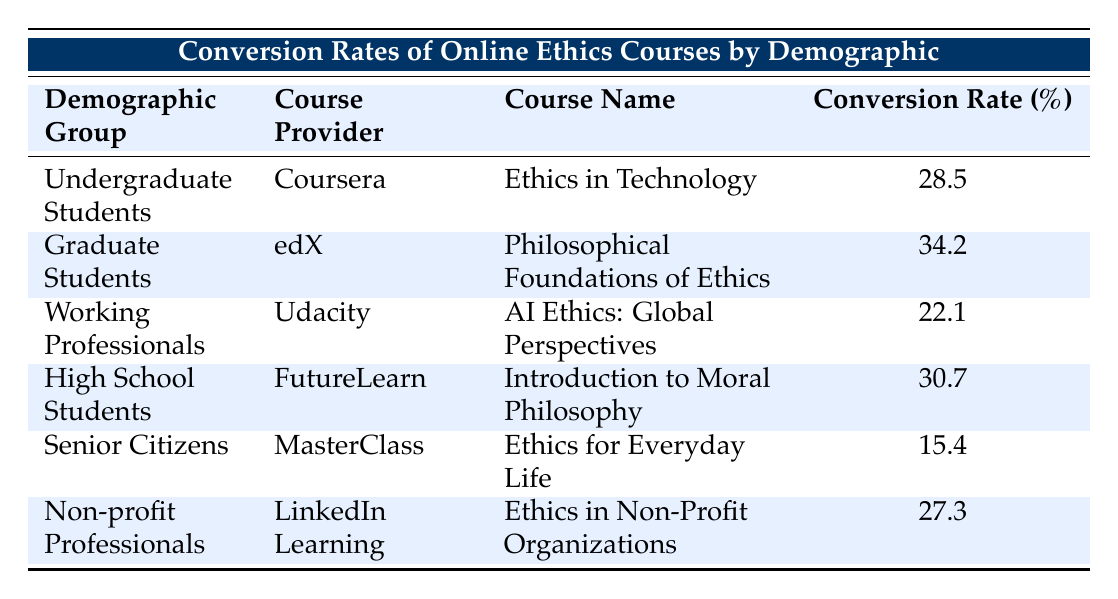What is the conversion rate for the course "AI Ethics: Global Perspectives"? The course "AI Ethics: Global Perspectives" is provided by Udacity for the demographic group of Working Professionals, which has a specified conversion rate of 22.1%.
Answer: 22.1% Which demographic group has the highest conversion rate for online ethics courses? The highest conversion rate is for Graduate Students with a conversion rate of 34.2% for the course "Philosophical Foundations of Ethics" provided by edX.
Answer: Graduate Students Calculate the average conversion rate for all demographic groups listed. First, we sum the conversion rates: 28.5 + 34.2 + 22.1 + 30.7 + 15.4 + 27.3 = 158.2. Then, we divide by the number of groups (6): 158.2 / 6 = 26.36.
Answer: 26.36 Is the conversion rate for Senior Citizens higher than that for Working Professionals? The conversion rate for Senior Citizens is 15.4%, and for Working Professionals, it is 22.1%. Since 15.4% is less than 22.1%, the statement is false.
Answer: No Which course provided by LinkedIn Learning has the lowest conversion rate among all courses listed? The lowest conversion rate among the courses is for "Ethics for Everyday Life" targeted at Senior Citizens, with a conversion rate of 15.4%. This is lower than the conversion rates for all other listed courses.
Answer: "Ethics for Everyday Life" 